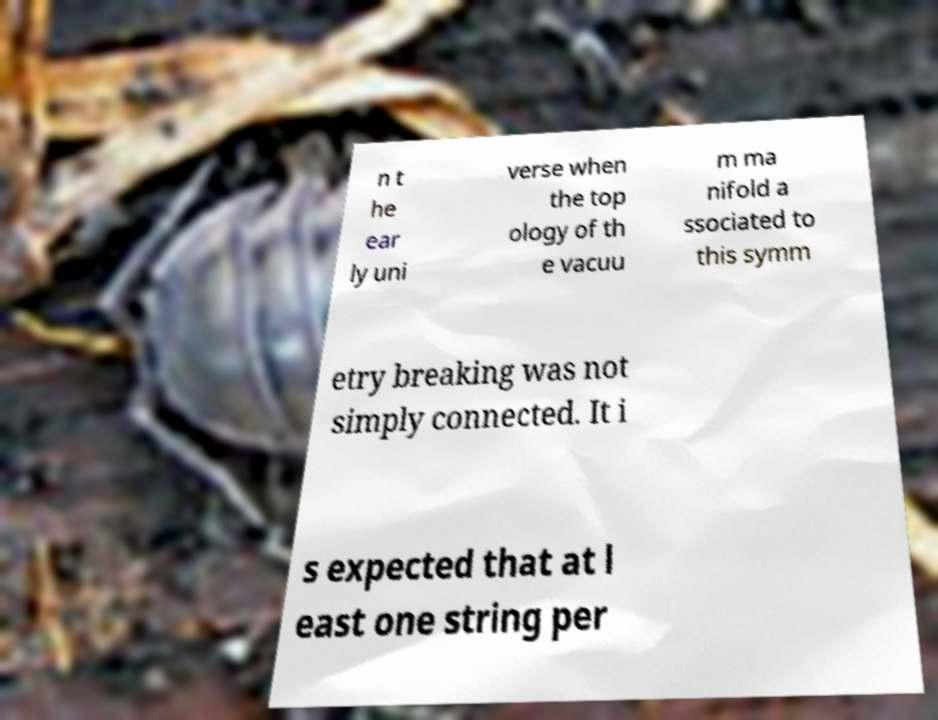Can you read and provide the text displayed in the image?This photo seems to have some interesting text. Can you extract and type it out for me? n t he ear ly uni verse when the top ology of th e vacuu m ma nifold a ssociated to this symm etry breaking was not simply connected. It i s expected that at l east one string per 